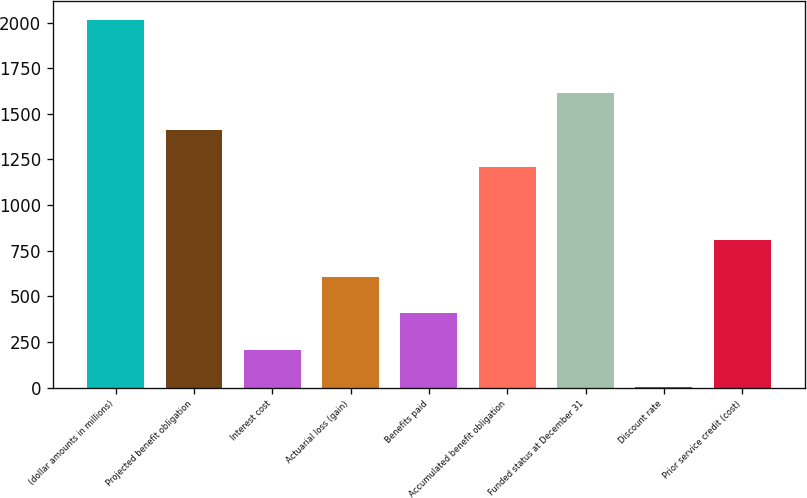<chart> <loc_0><loc_0><loc_500><loc_500><bar_chart><fcel>(dollar amounts in millions)<fcel>Projected benefit obligation<fcel>Interest cost<fcel>Actuarial loss (gain)<fcel>Benefits paid<fcel>Accumulated benefit obligation<fcel>Funded status at December 31<fcel>Discount rate<fcel>Prior service credit (cost)<nl><fcel>2015.02<fcel>1411.96<fcel>205.84<fcel>607.88<fcel>406.86<fcel>1210.94<fcel>1612.98<fcel>4.82<fcel>808.9<nl></chart> 